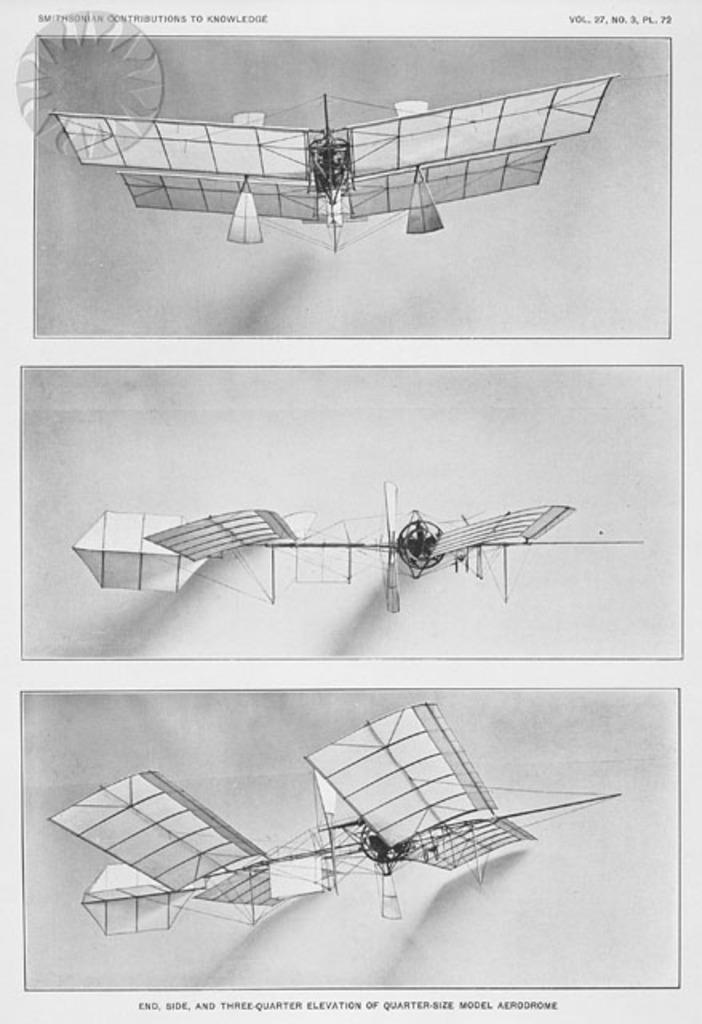What is the volume number of the publication that the page is taken out of?
Provide a short and direct response. 27. Which museum features this drawing?
Your answer should be very brief. Smithsonian. 